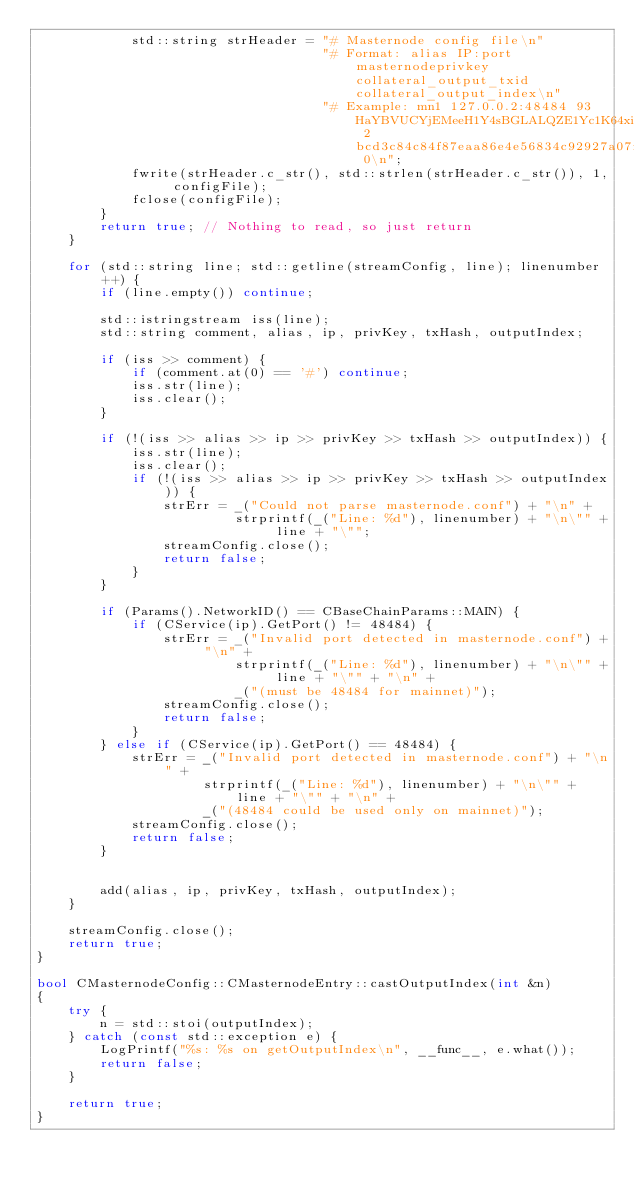<code> <loc_0><loc_0><loc_500><loc_500><_C++_>            std::string strHeader = "# Masternode config file\n"
                                    "# Format: alias IP:port masternodeprivkey collateral_output_txid collateral_output_index\n"
                                    "# Example: mn1 127.0.0.2:48484 93HaYBVUCYjEMeeH1Y4sBGLALQZE1Yc1K64xiqgX37tGBDQL8Xg 2bcd3c84c84f87eaa86e4e56834c92927a07f9e18718810b92e0d0324456a67c 0\n";
            fwrite(strHeader.c_str(), std::strlen(strHeader.c_str()), 1, configFile);
            fclose(configFile);
        }
        return true; // Nothing to read, so just return
    }

    for (std::string line; std::getline(streamConfig, line); linenumber++) {
        if (line.empty()) continue;

        std::istringstream iss(line);
        std::string comment, alias, ip, privKey, txHash, outputIndex;

        if (iss >> comment) {
            if (comment.at(0) == '#') continue;
            iss.str(line);
            iss.clear();
        }

        if (!(iss >> alias >> ip >> privKey >> txHash >> outputIndex)) {
            iss.str(line);
            iss.clear();
            if (!(iss >> alias >> ip >> privKey >> txHash >> outputIndex)) {
                strErr = _("Could not parse masternode.conf") + "\n" +
                         strprintf(_("Line: %d"), linenumber) + "\n\"" + line + "\"";
                streamConfig.close();
                return false;
            }
        }

        if (Params().NetworkID() == CBaseChainParams::MAIN) {
            if (CService(ip).GetPort() != 48484) {
                strErr = _("Invalid port detected in masternode.conf") + "\n" +
                         strprintf(_("Line: %d"), linenumber) + "\n\"" + line + "\"" + "\n" +
                         _("(must be 48484 for mainnet)");
                streamConfig.close();
                return false;
            }
        } else if (CService(ip).GetPort() == 48484) {
            strErr = _("Invalid port detected in masternode.conf") + "\n" +
                     strprintf(_("Line: %d"), linenumber) + "\n\"" + line + "\"" + "\n" +
                     _("(48484 could be used only on mainnet)");
            streamConfig.close();
            return false;
        }


        add(alias, ip, privKey, txHash, outputIndex);
    }

    streamConfig.close();
    return true;
}

bool CMasternodeConfig::CMasternodeEntry::castOutputIndex(int &n)
{
    try {
        n = std::stoi(outputIndex);
    } catch (const std::exception e) {
        LogPrintf("%s: %s on getOutputIndex\n", __func__, e.what());
        return false;
    }

    return true;
}</code> 